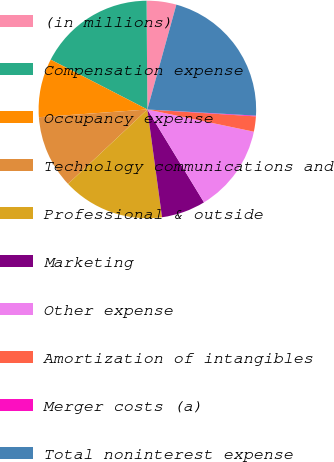<chart> <loc_0><loc_0><loc_500><loc_500><pie_chart><fcel>(in millions)<fcel>Compensation expense<fcel>Occupancy expense<fcel>Technology communications and<fcel>Professional & outside<fcel>Marketing<fcel>Other expense<fcel>Amortization of intangibles<fcel>Merger costs (a)<fcel>Total noninterest expense<nl><fcel>4.41%<fcel>17.31%<fcel>8.71%<fcel>10.86%<fcel>15.16%<fcel>6.56%<fcel>13.01%<fcel>2.26%<fcel>0.11%<fcel>21.61%<nl></chart> 